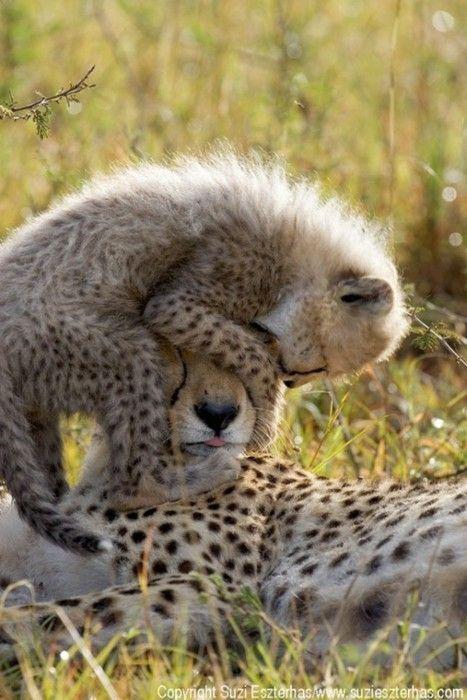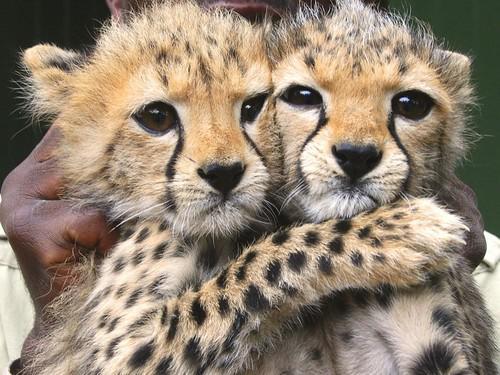The first image is the image on the left, the second image is the image on the right. Analyze the images presented: Is the assertion "A spotted adult wildcat is carrying a dangling kitten in its mouth in one image." valid? Answer yes or no. No. The first image is the image on the left, the second image is the image on the right. Analyze the images presented: Is the assertion "The left image contains two cheetahs." valid? Answer yes or no. Yes. 